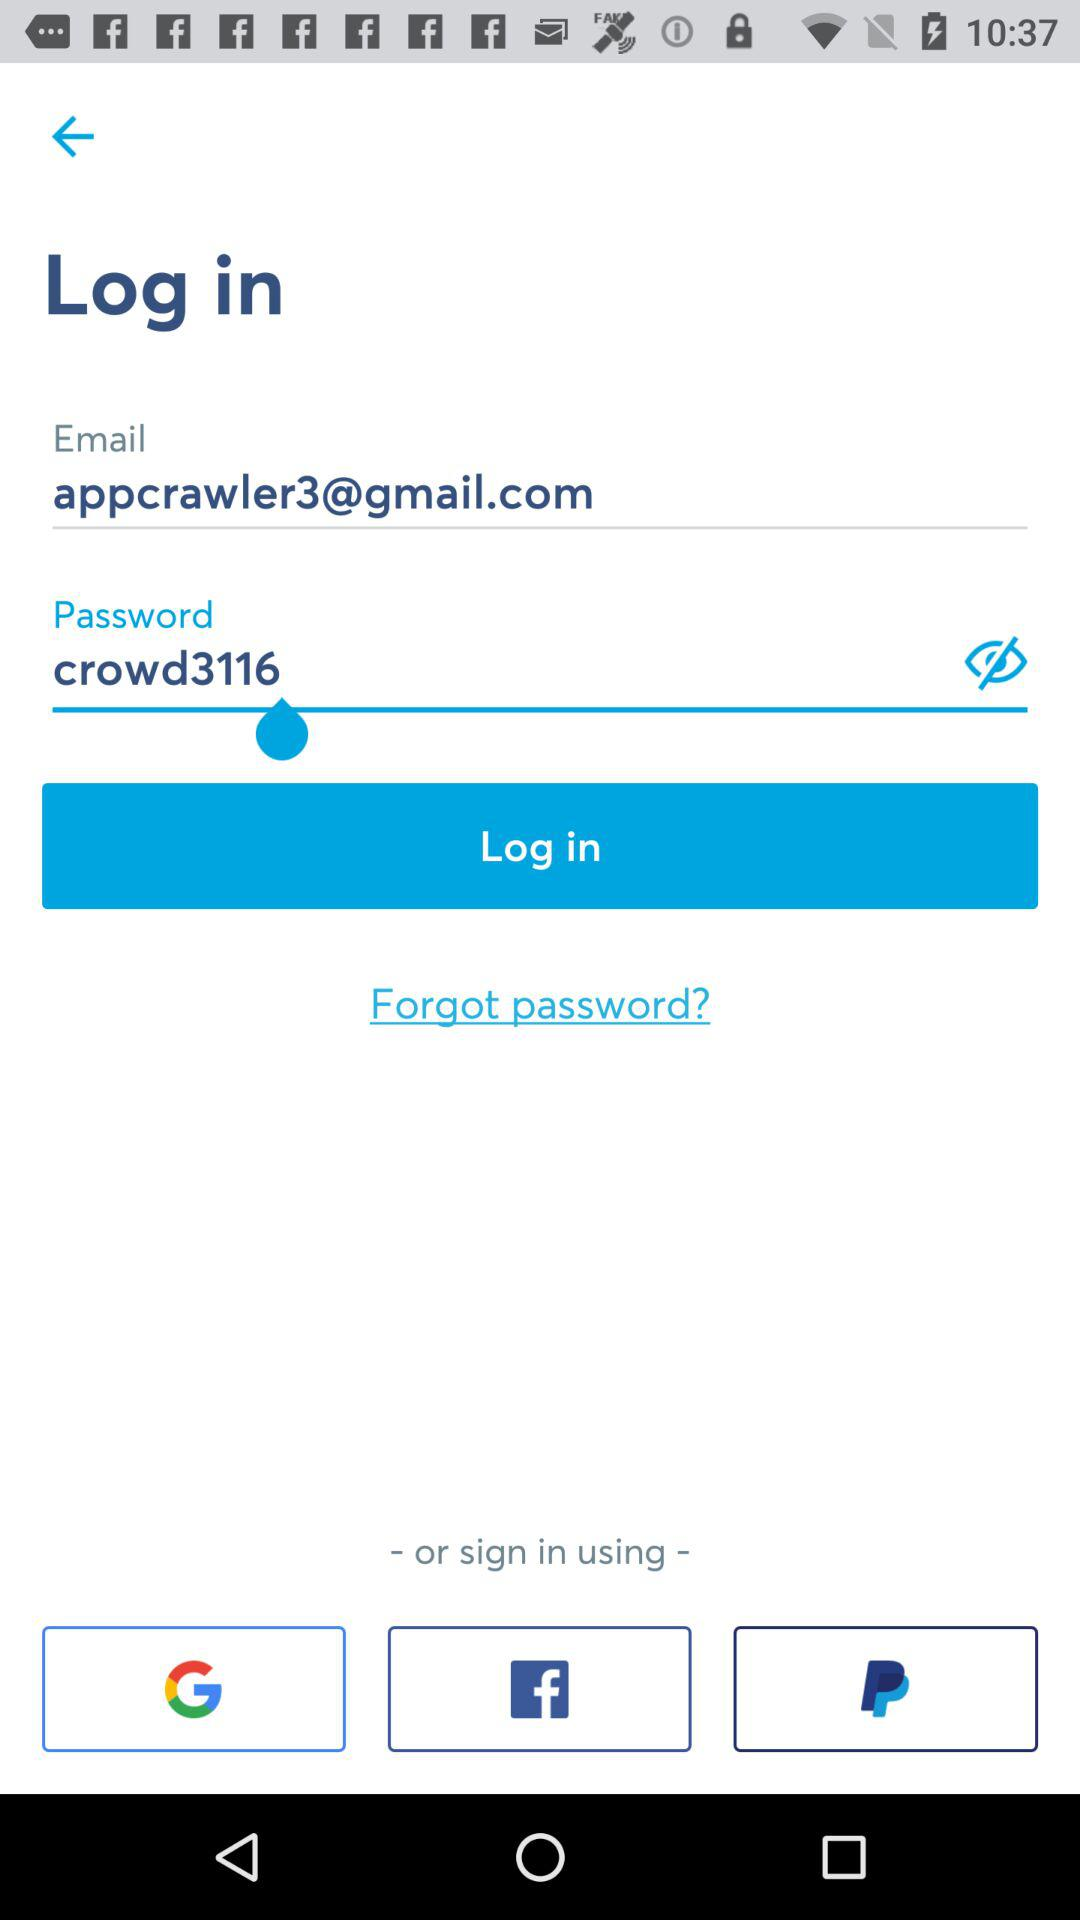What is the password? The password is "crowd3116". 